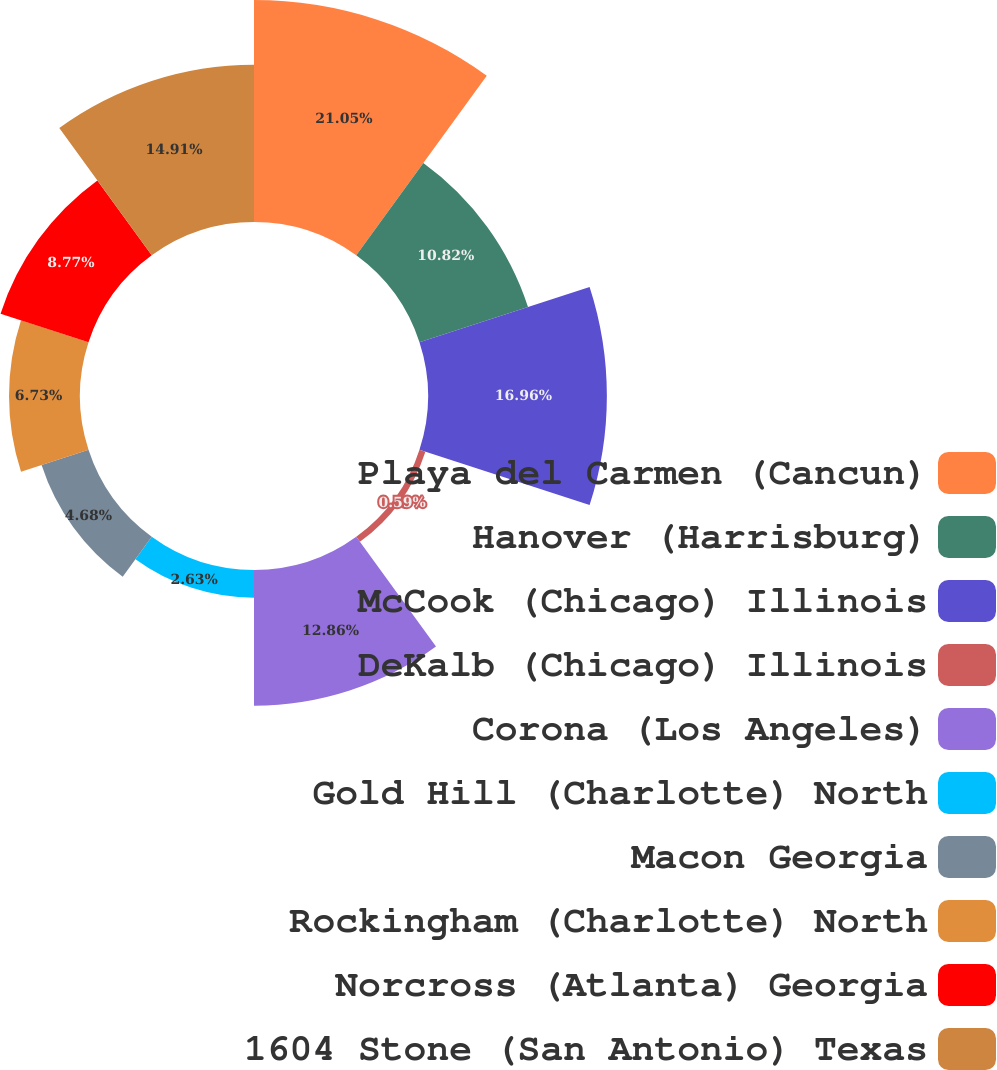Convert chart. <chart><loc_0><loc_0><loc_500><loc_500><pie_chart><fcel>Playa del Carmen (Cancun)<fcel>Hanover (Harrisburg)<fcel>McCook (Chicago) Illinois<fcel>DeKalb (Chicago) Illinois<fcel>Corona (Los Angeles)<fcel>Gold Hill (Charlotte) North<fcel>Macon Georgia<fcel>Rockingham (Charlotte) North<fcel>Norcross (Atlanta) Georgia<fcel>1604 Stone (San Antonio) Texas<nl><fcel>21.05%<fcel>10.82%<fcel>16.96%<fcel>0.59%<fcel>12.86%<fcel>2.63%<fcel>4.68%<fcel>6.73%<fcel>8.77%<fcel>14.91%<nl></chart> 